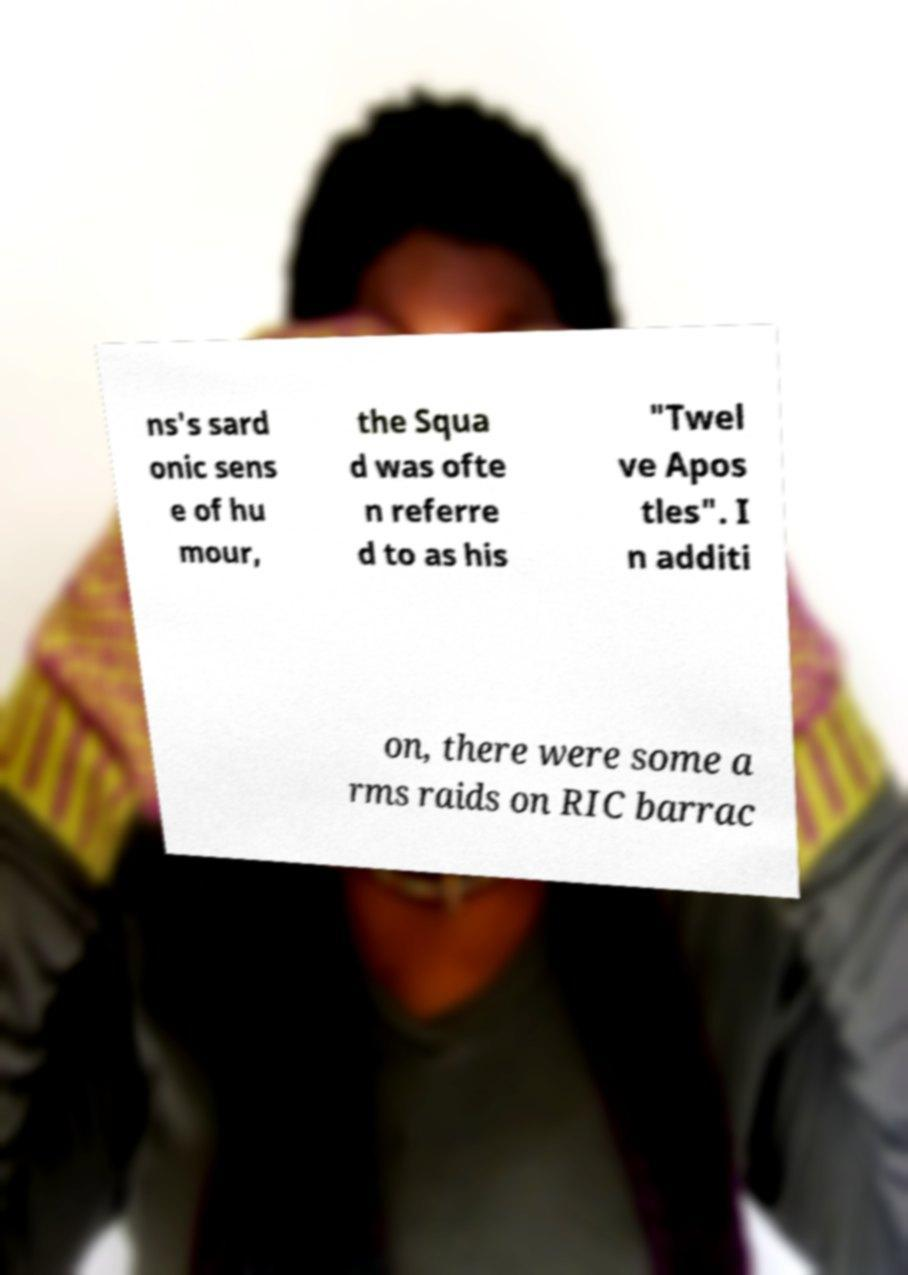Can you read and provide the text displayed in the image?This photo seems to have some interesting text. Can you extract and type it out for me? ns's sard onic sens e of hu mour, the Squa d was ofte n referre d to as his "Twel ve Apos tles". I n additi on, there were some a rms raids on RIC barrac 